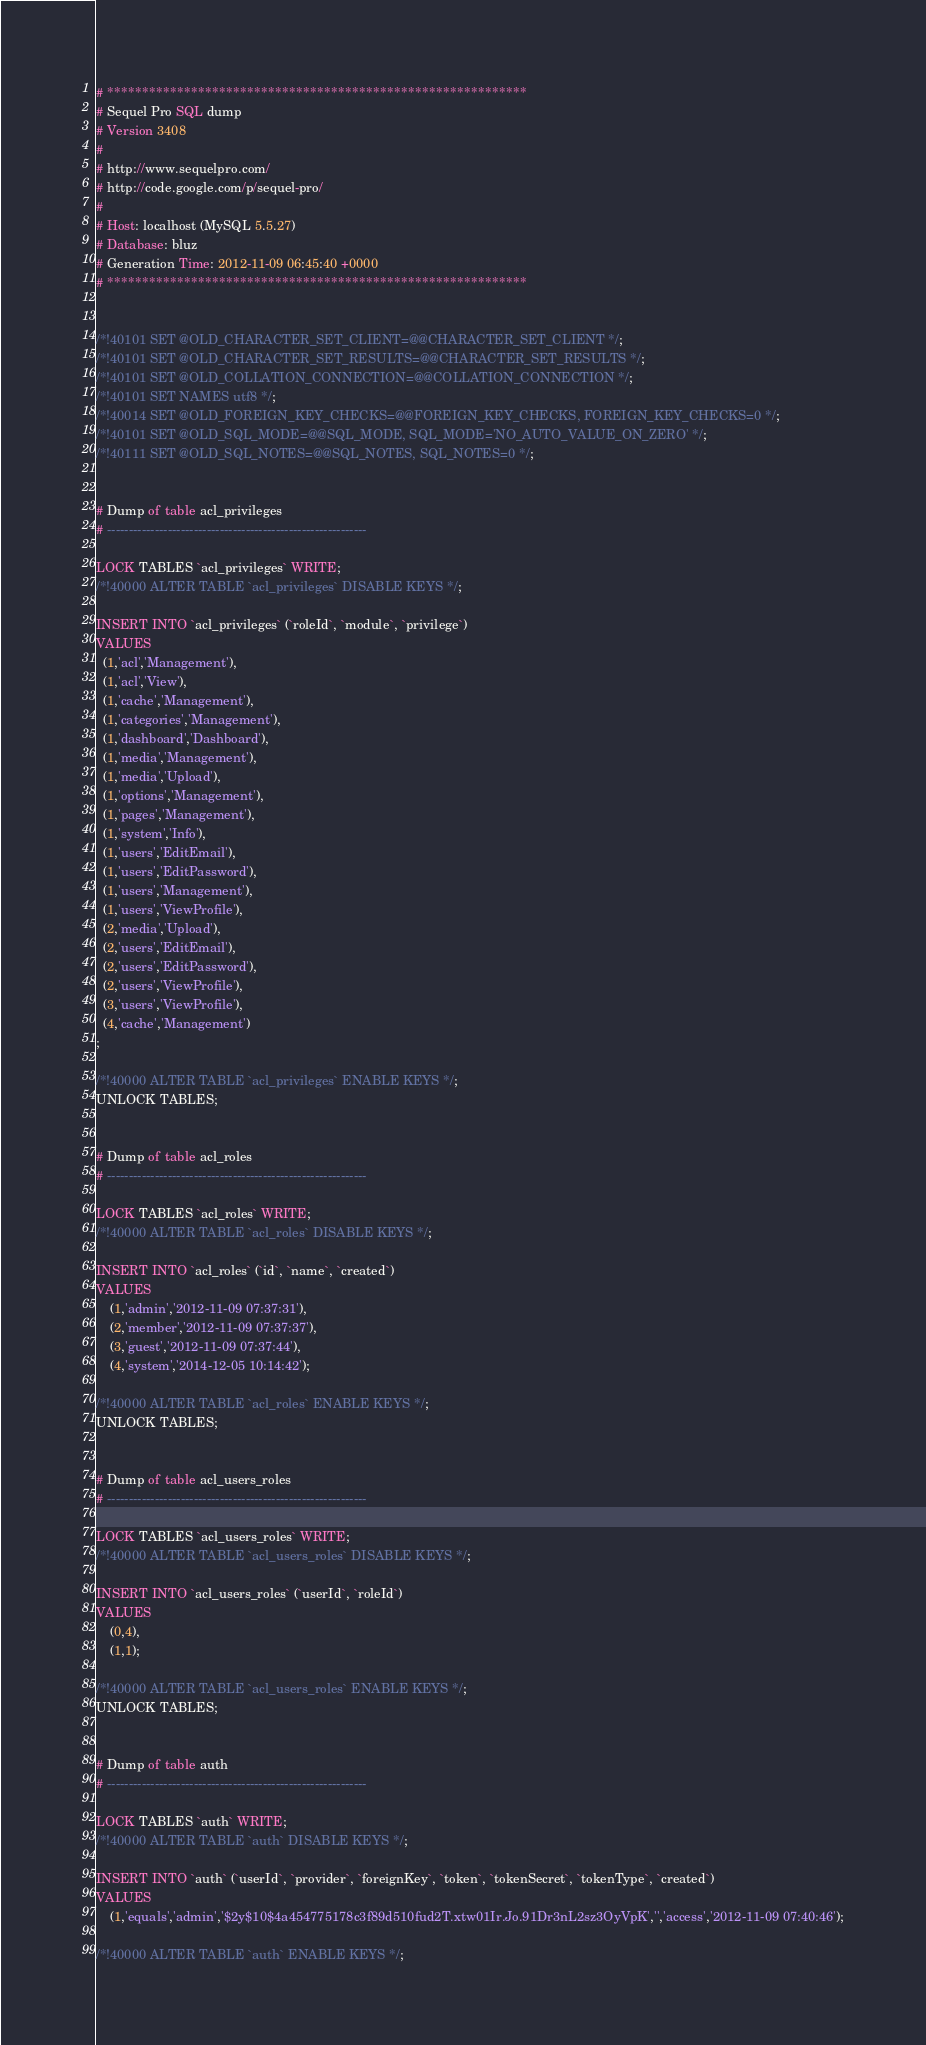<code> <loc_0><loc_0><loc_500><loc_500><_SQL_># ************************************************************
# Sequel Pro SQL dump
# Version 3408
#
# http://www.sequelpro.com/
# http://code.google.com/p/sequel-pro/
#
# Host: localhost (MySQL 5.5.27)
# Database: bluz
# Generation Time: 2012-11-09 06:45:40 +0000
# ************************************************************


/*!40101 SET @OLD_CHARACTER_SET_CLIENT=@@CHARACTER_SET_CLIENT */;
/*!40101 SET @OLD_CHARACTER_SET_RESULTS=@@CHARACTER_SET_RESULTS */;
/*!40101 SET @OLD_COLLATION_CONNECTION=@@COLLATION_CONNECTION */;
/*!40101 SET NAMES utf8 */;
/*!40014 SET @OLD_FOREIGN_KEY_CHECKS=@@FOREIGN_KEY_CHECKS, FOREIGN_KEY_CHECKS=0 */;
/*!40101 SET @OLD_SQL_MODE=@@SQL_MODE, SQL_MODE='NO_AUTO_VALUE_ON_ZERO' */;
/*!40111 SET @OLD_SQL_NOTES=@@SQL_NOTES, SQL_NOTES=0 */;


# Dump of table acl_privileges
# ------------------------------------------------------------

LOCK TABLES `acl_privileges` WRITE;
/*!40000 ALTER TABLE `acl_privileges` DISABLE KEYS */;

INSERT INTO `acl_privileges` (`roleId`, `module`, `privilege`)
VALUES
  (1,'acl','Management'),
  (1,'acl','View'),
  (1,'cache','Management'),
  (1,'categories','Management'),
  (1,'dashboard','Dashboard'),
  (1,'media','Management'),
  (1,'media','Upload'),
  (1,'options','Management'),
  (1,'pages','Management'),
  (1,'system','Info'),
  (1,'users','EditEmail'),
  (1,'users','EditPassword'),
  (1,'users','Management'),
  (1,'users','ViewProfile'),
  (2,'media','Upload'),
  (2,'users','EditEmail'),
  (2,'users','EditPassword'),
  (2,'users','ViewProfile'),
  (3,'users','ViewProfile'),
  (4,'cache','Management')
;

/*!40000 ALTER TABLE `acl_privileges` ENABLE KEYS */;
UNLOCK TABLES;


# Dump of table acl_roles
# ------------------------------------------------------------

LOCK TABLES `acl_roles` WRITE;
/*!40000 ALTER TABLE `acl_roles` DISABLE KEYS */;

INSERT INTO `acl_roles` (`id`, `name`, `created`)
VALUES
	(1,'admin','2012-11-09 07:37:31'),
	(2,'member','2012-11-09 07:37:37'),
	(3,'guest','2012-11-09 07:37:44'),
	(4,'system','2014-12-05 10:14:42');

/*!40000 ALTER TABLE `acl_roles` ENABLE KEYS */;
UNLOCK TABLES;


# Dump of table acl_users_roles
# ------------------------------------------------------------

LOCK TABLES `acl_users_roles` WRITE;
/*!40000 ALTER TABLE `acl_users_roles` DISABLE KEYS */;

INSERT INTO `acl_users_roles` (`userId`, `roleId`)
VALUES
	(0,4),
	(1,1);

/*!40000 ALTER TABLE `acl_users_roles` ENABLE KEYS */;
UNLOCK TABLES;


# Dump of table auth
# ------------------------------------------------------------

LOCK TABLES `auth` WRITE;
/*!40000 ALTER TABLE `auth` DISABLE KEYS */;

INSERT INTO `auth` (`userId`, `provider`, `foreignKey`, `token`, `tokenSecret`, `tokenType`, `created`)
VALUES
	(1,'equals','admin','$2y$10$4a454775178c3f89d510fud2T.xtw01Ir.Jo.91Dr3nL2sz3OyVpK','','access','2012-11-09 07:40:46');

/*!40000 ALTER TABLE `auth` ENABLE KEYS */;</code> 